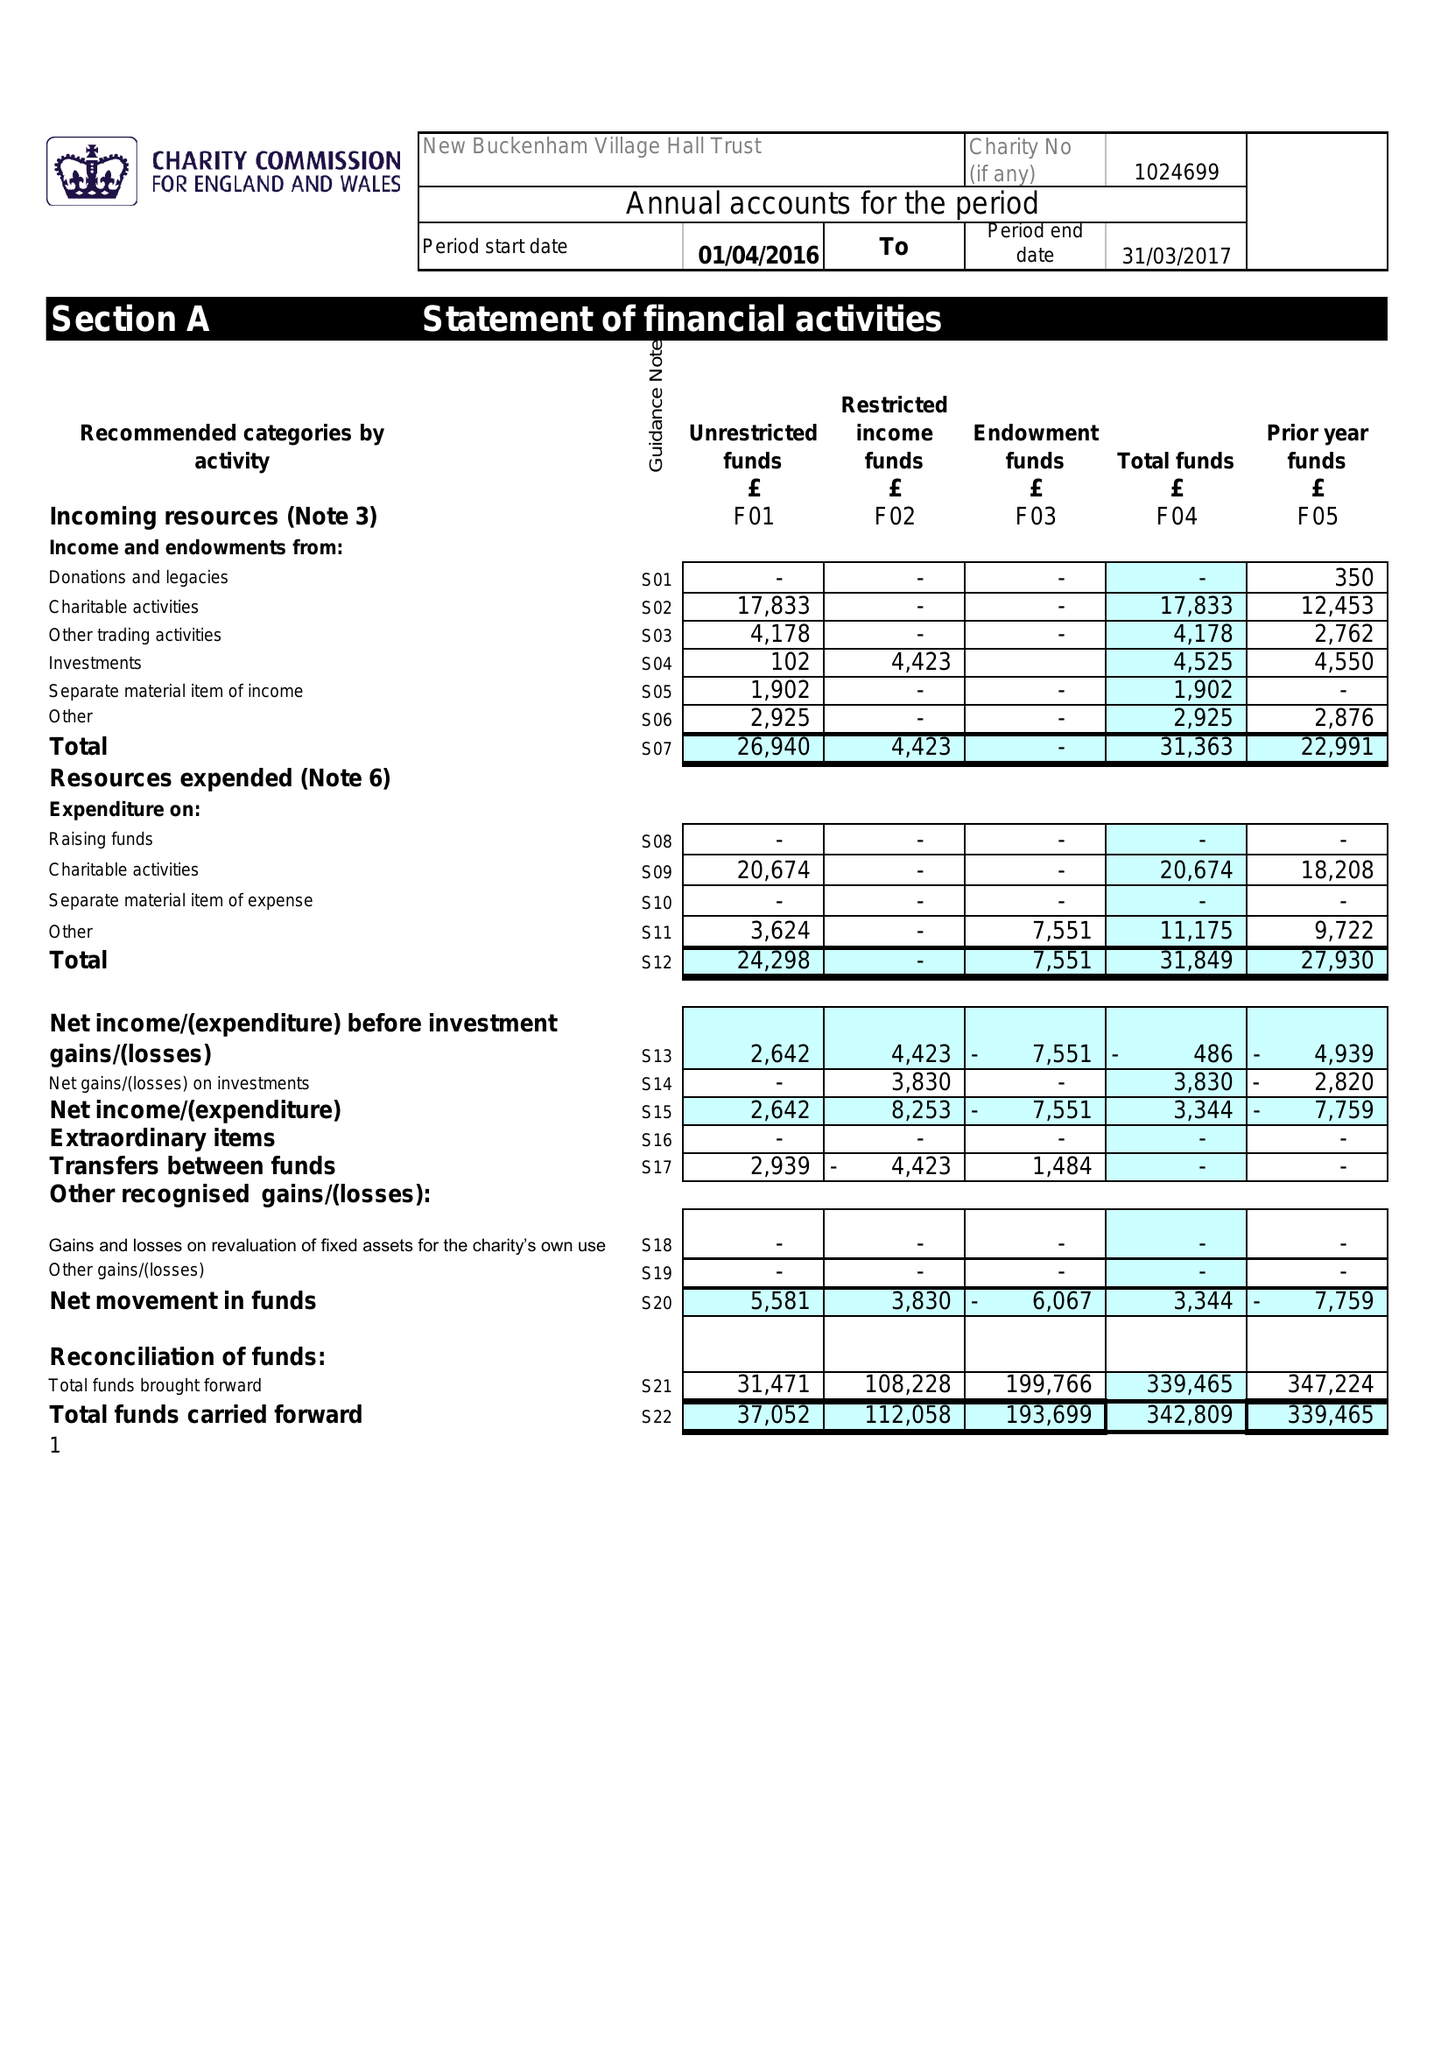What is the value for the address__postcode?
Answer the question using a single word or phrase. NR16 2AU 